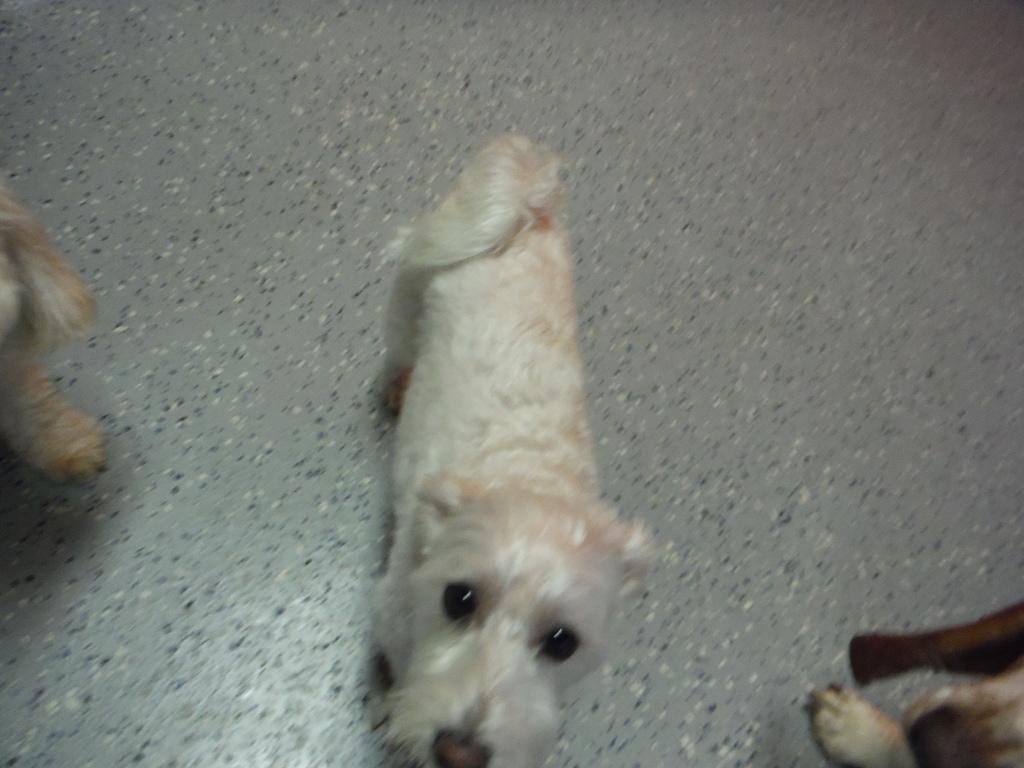Can you describe this image briefly? In the image we can see three dogs of different colors, on the floor. 